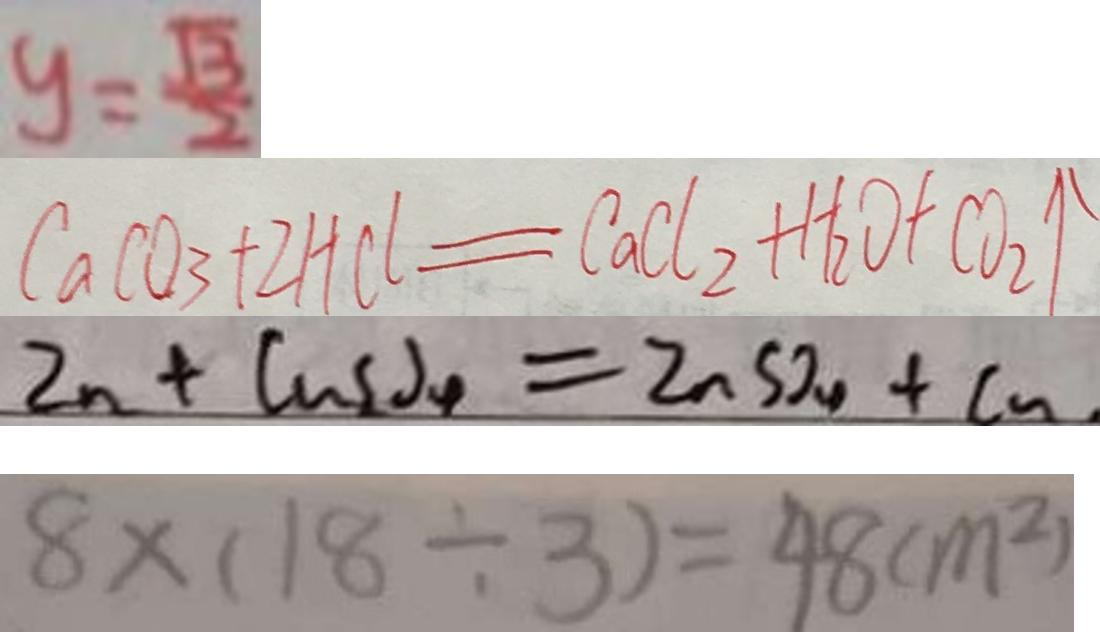Convert formula to latex. <formula><loc_0><loc_0><loc_500><loc_500>y = \frac { \sqrt { 3 } } { 2 } 
 C a C O _ { 3 } + 2 H C l = C a C l _ { 2 } + H _ { 2 } O + C O _ { 2 } \uparrow 
 Z n + C u S O _ { 4 } = Z n S O _ { 4 } + C u 
 8 \times ( 1 8 \div 3 ) = 4 8 ( m ^ { 2 } )</formula> 